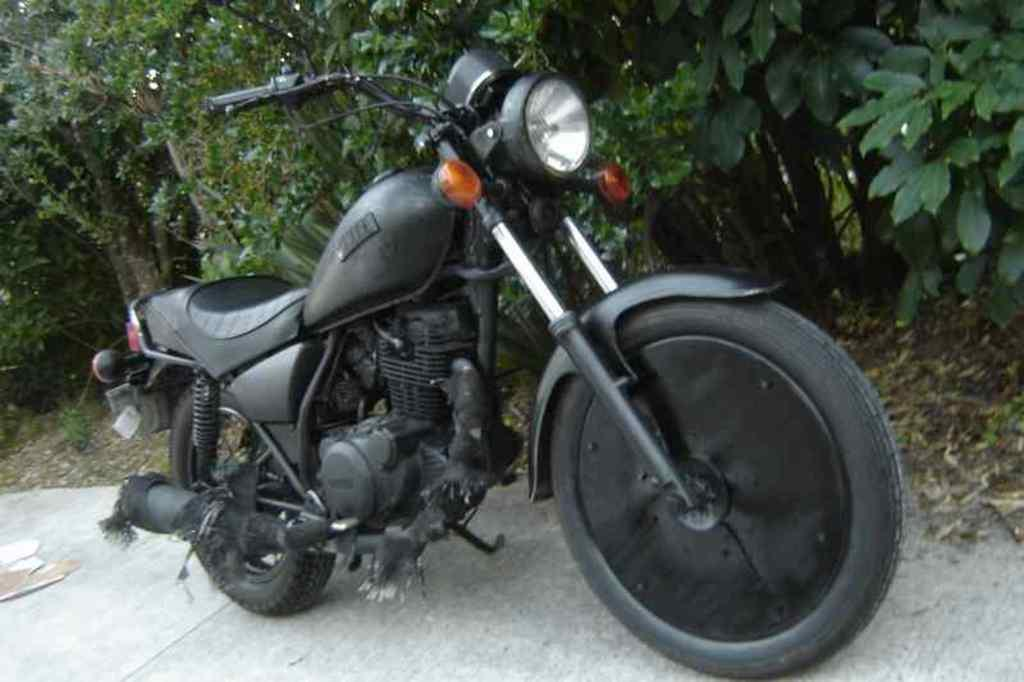What is the main subject in the center of the image? There is a bike in the center of the image. What can be seen in the background of the image? There are trees in the background of the image. What is located at the bottom of the image? There is a road at the bottom of the image. Can you see a rabbit hopping on the road in the image? There is no rabbit present in the image; it only features a bike, trees, and a road. Is there any salt visible on the bike in the image? There is no salt present on the bike or anywhere else in the image. 